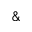Convert formula to latex. <formula><loc_0><loc_0><loc_500><loc_500>\&</formula> 